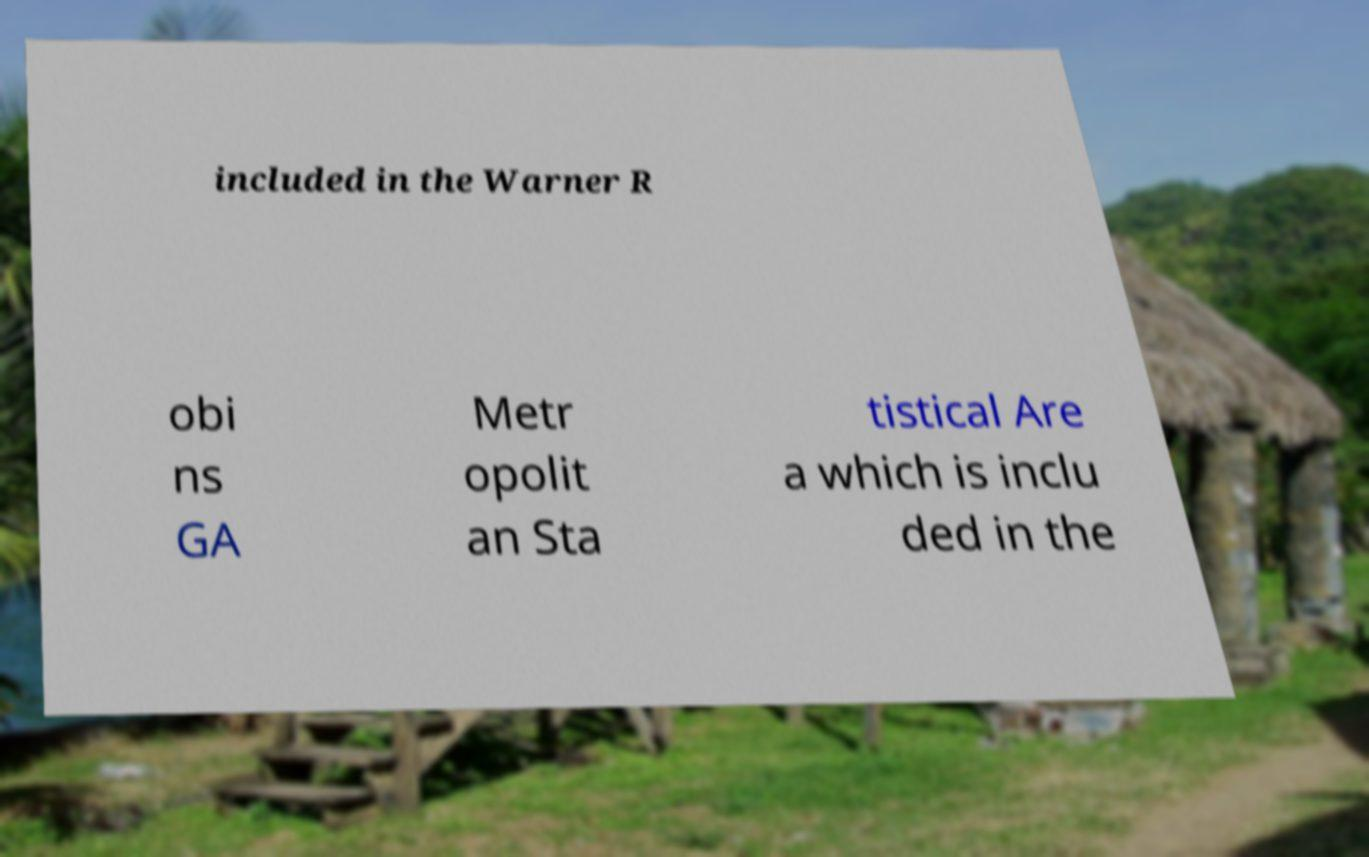Can you accurately transcribe the text from the provided image for me? included in the Warner R obi ns GA Metr opolit an Sta tistical Are a which is inclu ded in the 